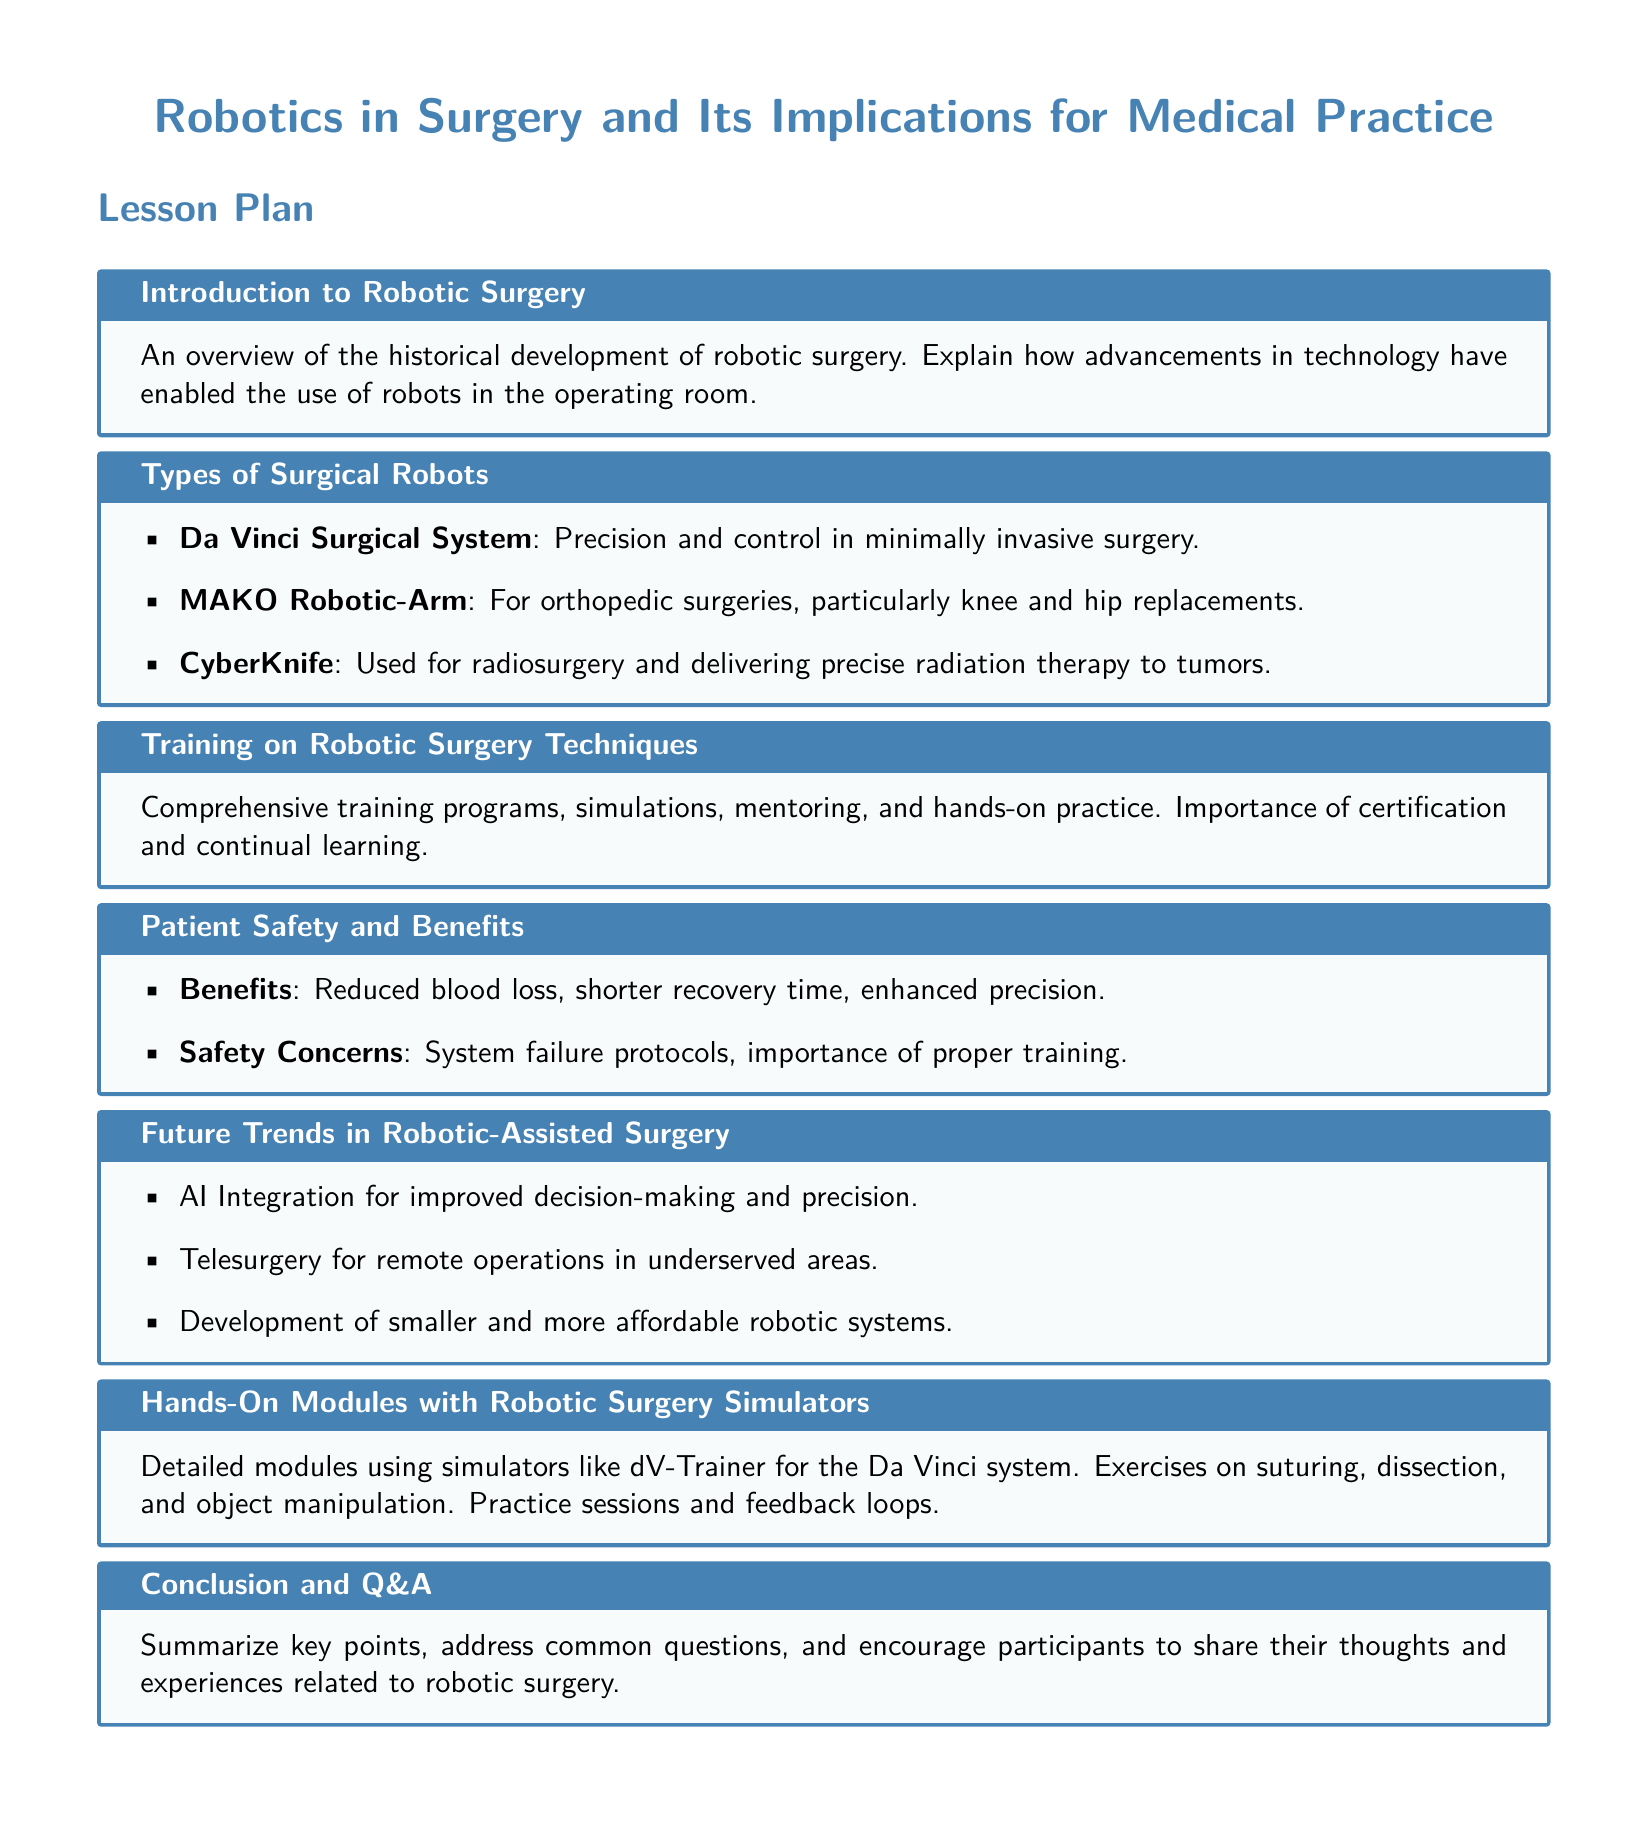What is the title of the lesson plan? The title can be found at the top of the document, which sets the theme for the lesson's content.
Answer: Robotics in Surgery and Its Implications for Medical Practice What surgical robot is used for orthopedic surgeries? The document lists specific types of surgical robots, including the one mentioned for orthopedic procedures.
Answer: MAKO Robotic-Arm What simulation system is mentioned for practicing the Da Vinci system? The document includes various training methods and specifies a particular simulator for hands-on training.
Answer: dV-Trainer What are the key benefits of robotic surgery? Benefits of robotic surgery are listed in the section discussing patient safety and advantages, succinctly summarizing the positive outcomes.
Answer: Reduced blood loss, shorter recovery time, enhanced precision What is one future trend in robotic-assisted surgery? The document outlines potential future advancements and innovations in the field of robotic surgery.
Answer: AI Integration for improved decision-making and precision How is training on robotic surgery described in the document? The training section provides insights into the structure and importance of training programs, emphasizing a thorough approach.
Answer: Comprehensive training programs, simulations, mentoring, and hands-on practice What does the conclusion section include? The conclusion is defined in the document as a wrap-up of key points along with an interactive element.
Answer: Summarize key points, address common questions, and encourage participants to share their thoughts and experiences 